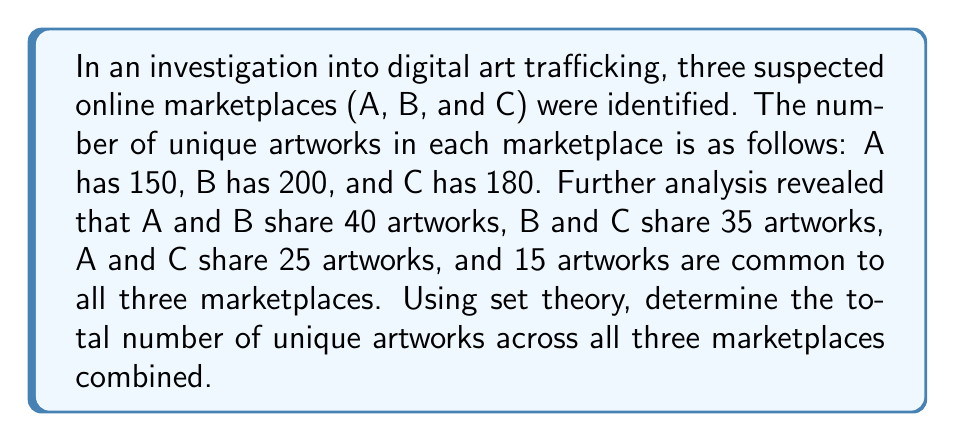Can you answer this question? To solve this problem, we can use the principle of inclusion-exclusion from set theory. Let's break it down step-by-step:

1) Let's define our sets:
   A = artworks in marketplace A
   B = artworks in marketplace B
   C = artworks in marketplace C

2) We're given:
   $|A| = 150$, $|B| = 200$, $|C| = 180$
   $|A \cap B| = 40$, $|B \cap C| = 35$, $|A \cap C| = 25$
   $|A \cap B \cap C| = 15$

3) The principle of inclusion-exclusion for three sets states:

   $$|A \cup B \cup C| = |A| + |B| + |C| - |A \cap B| - |B \cap C| - |A \cap C| + |A \cap B \cap C|$$

4) Let's substitute our known values:

   $$|A \cup B \cup C| = 150 + 200 + 180 - 40 - 35 - 25 + 15$$

5) Now we can calculate:

   $$|A \cup B \cup C| = 530 - 100 + 15 = 445$$

Therefore, the total number of unique artworks across all three marketplaces is 445.
Answer: 445 unique artworks 